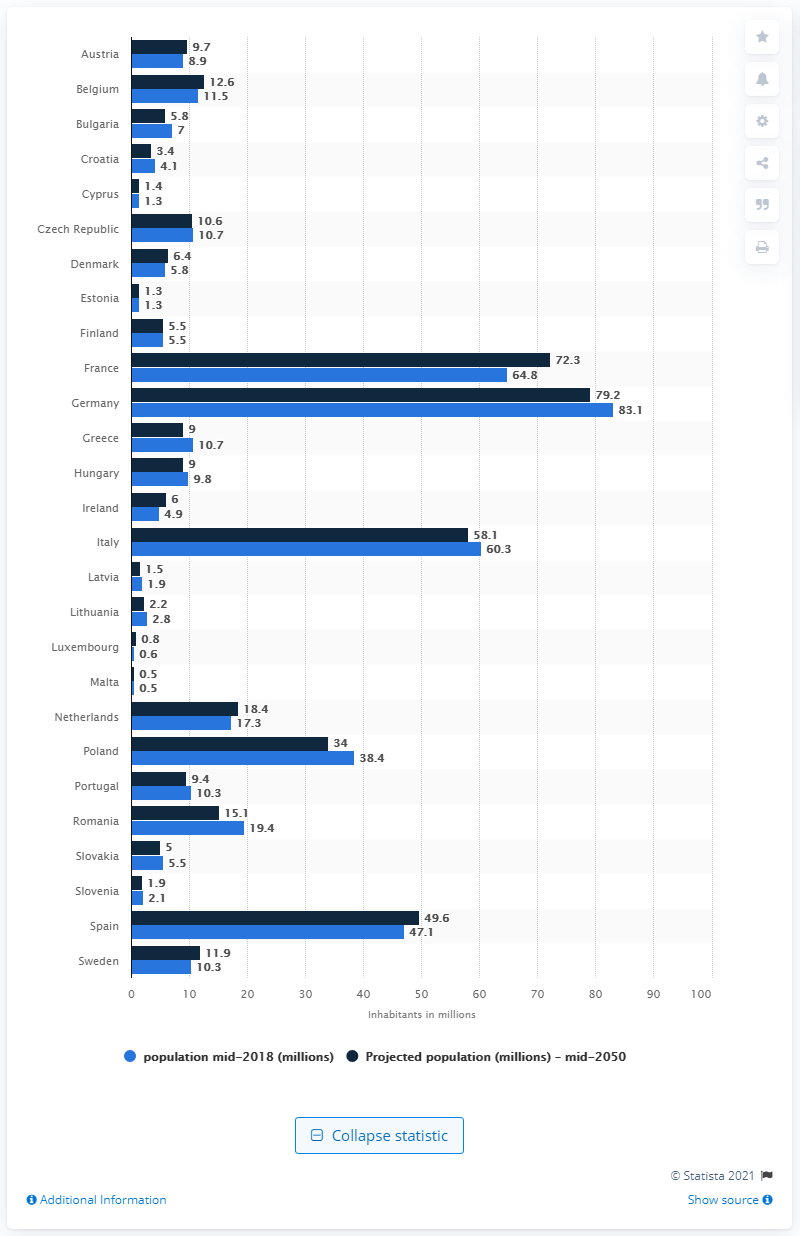How many people will live in Germany in 2050? According to the projection data in the image, it is estimated that the population of Germany will be approximately 79.2 million people by the middle of 2050. It's worth noting that population forecasts can change due to various factors such as migration patterns, birth rates, and policies. 